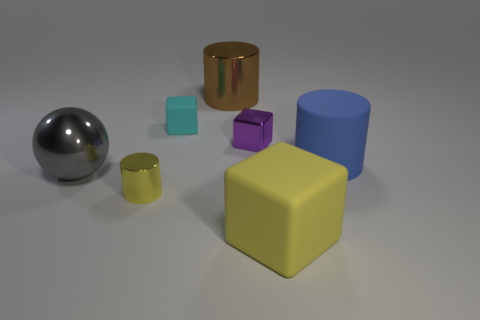What size is the rubber cube that is the same color as the tiny metallic cylinder?
Your response must be concise. Large. What is the material of the tiny object that is the same color as the large rubber block?
Your answer should be compact. Metal. There is a large block that is made of the same material as the blue object; what color is it?
Make the answer very short. Yellow. Are there more small purple cubes than big blue matte spheres?
Ensure brevity in your answer.  Yes. Is the material of the purple object the same as the yellow cylinder?
Provide a short and direct response. Yes. There is a brown thing that is made of the same material as the purple object; what is its shape?
Your response must be concise. Cylinder. Is the number of large blue objects less than the number of red cylinders?
Your answer should be very brief. No. There is a big object that is right of the large brown shiny thing and behind the big yellow thing; what material is it made of?
Keep it short and to the point. Rubber. There is a cylinder left of the big cylinder that is behind the large matte thing that is right of the big rubber block; what size is it?
Your answer should be compact. Small. Does the purple thing have the same shape as the small object that is in front of the large blue rubber cylinder?
Offer a terse response. No. 